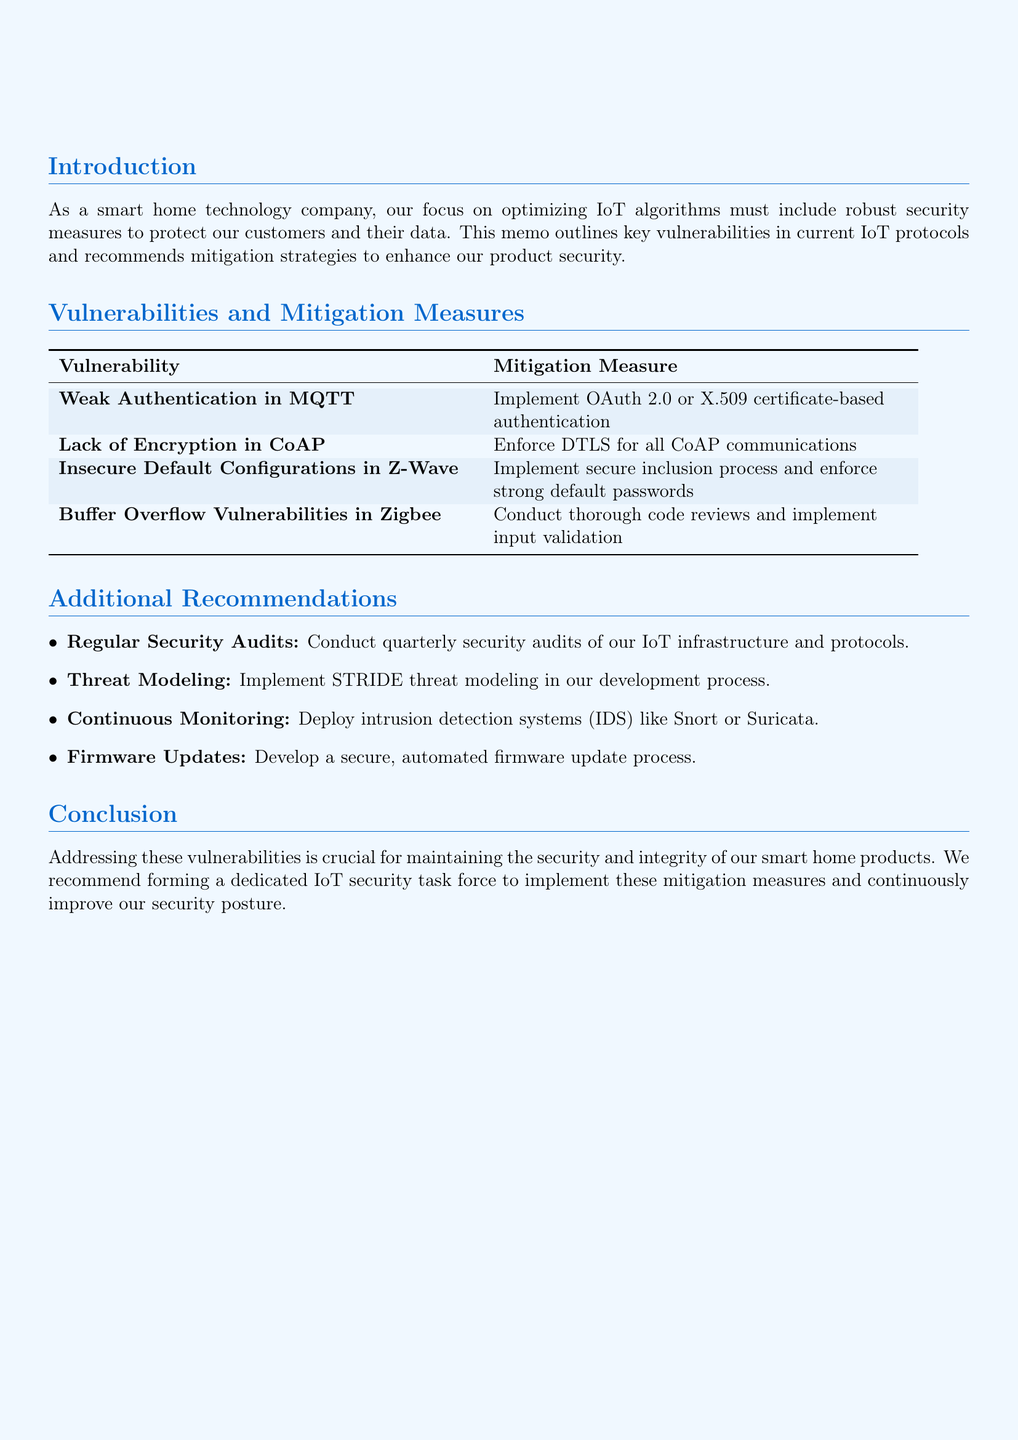what is the title of the memo? The title of the memo is provided at the top of the document.
Answer: Security Vulnerabilities in IoT Protocols and Mitigation Strategies what is the first vulnerability listed? The vulnerabilities are listed in a specific order, with the first one being identified.
Answer: Weak Authentication in MQTT how many vulnerabilities are identified in total? The total number of vulnerabilities is explicitly stated in the document.
Answer: Four what is the recommended mitigation measure for CoAP? The document specifies the mitigation measures corresponding to each vulnerability.
Answer: Enforce DTLS for all CoAP communications which additional recommendation involves regular checks? The additional recommendations are listed, and one specifically mentions the frequency of checks.
Answer: Regular Security Audits what is the impact of insecure default configurations in Z-Wave? The impact of each vulnerability is detailed, including the consequences of insecure configurations.
Answer: Unauthorized control of smart home devices and potential for large-scale attacks what is the last additional recommendation in the document? The additional recommendations are listed in sequence, with the last one being identifiable.
Answer: Develop a secure, automated firmware update process what type of modeling is recommended in the additional recommendations? The document provides specific approaches under additional recommendations, one of which pertains to modeling.
Answer: STRIDE threat modeling what is the purpose of this memo? The purpose of the memo is stated in the introduction section, explaining its intention.
Answer: This memo outlines key vulnerabilities in current IoT protocols and recommends mitigation strategies to enhance our product security 